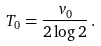Convert formula to latex. <formula><loc_0><loc_0><loc_500><loc_500>T _ { 0 } = \frac { v _ { 0 } } { 2 \log 2 } \, .</formula> 